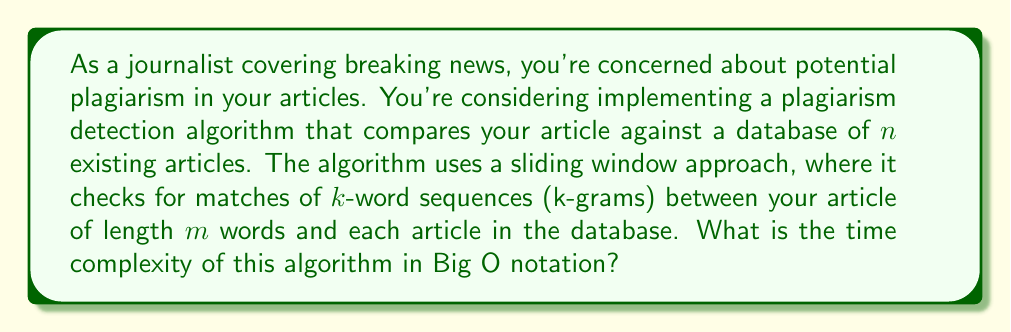What is the answer to this math problem? To analyze the time complexity of this plagiarism detection algorithm, let's break it down step by step:

1. For each article in the database (n articles):
   - We need to compare our article against it
   
2. For each comparison:
   - We use a sliding window of k words (k-gram) on our article
   - The number of k-grams in our article is $(m - k + 1)$
   
3. For each k-gram:
   - We need to check if it exists in the current database article
   - This check can be done in constant time $O(1)$ using efficient string matching algorithms like Rabin-Karp or using a hash table

Therefore, the total number of operations is:

$$n \cdot (m - k + 1) \cdot O(1)$$

Simplifying:
- Since $k$ is typically much smaller than $m$, we can approximate $(m - k + 1)$ as $m$
- The constant factor $O(1)$ doesn't affect the overall complexity

This gives us:

$$O(n \cdot m)$$

This means the time complexity grows linearly with both the number of articles in the database and the length of the article being checked.
Answer: $O(nm)$, where $n$ is the number of articles in the database and $m$ is the length of the article being checked. 